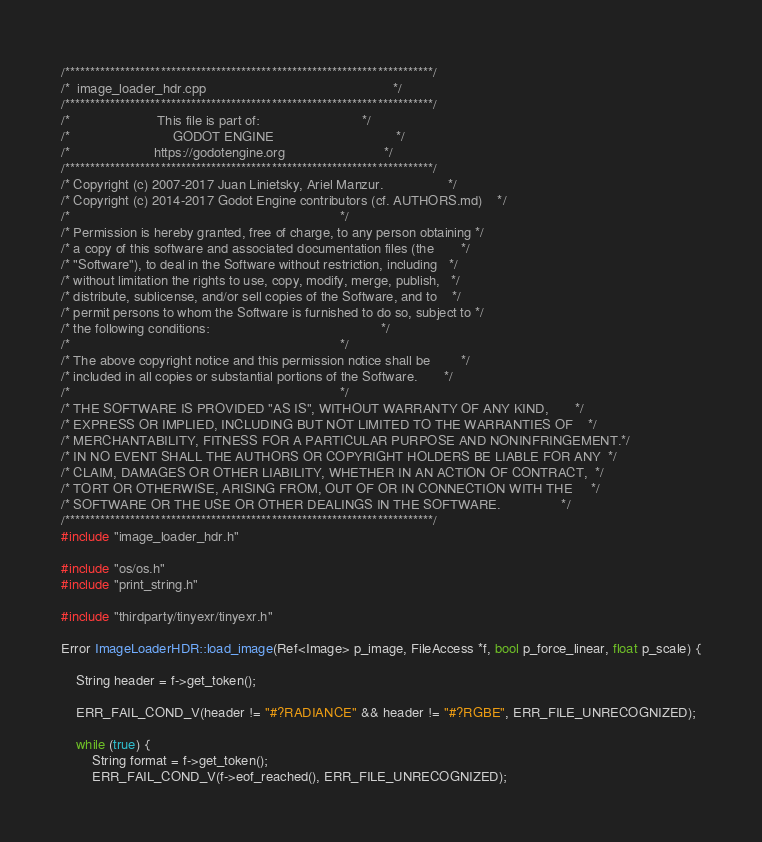<code> <loc_0><loc_0><loc_500><loc_500><_C++_>/*************************************************************************/
/*  image_loader_hdr.cpp                                                 */
/*************************************************************************/
/*                       This file is part of:                           */
/*                           GODOT ENGINE                                */
/*                      https://godotengine.org                          */
/*************************************************************************/
/* Copyright (c) 2007-2017 Juan Linietsky, Ariel Manzur.                 */
/* Copyright (c) 2014-2017 Godot Engine contributors (cf. AUTHORS.md)    */
/*                                                                       */
/* Permission is hereby granted, free of charge, to any person obtaining */
/* a copy of this software and associated documentation files (the       */
/* "Software"), to deal in the Software without restriction, including   */
/* without limitation the rights to use, copy, modify, merge, publish,   */
/* distribute, sublicense, and/or sell copies of the Software, and to    */
/* permit persons to whom the Software is furnished to do so, subject to */
/* the following conditions:                                             */
/*                                                                       */
/* The above copyright notice and this permission notice shall be        */
/* included in all copies or substantial portions of the Software.       */
/*                                                                       */
/* THE SOFTWARE IS PROVIDED "AS IS", WITHOUT WARRANTY OF ANY KIND,       */
/* EXPRESS OR IMPLIED, INCLUDING BUT NOT LIMITED TO THE WARRANTIES OF    */
/* MERCHANTABILITY, FITNESS FOR A PARTICULAR PURPOSE AND NONINFRINGEMENT.*/
/* IN NO EVENT SHALL THE AUTHORS OR COPYRIGHT HOLDERS BE LIABLE FOR ANY  */
/* CLAIM, DAMAGES OR OTHER LIABILITY, WHETHER IN AN ACTION OF CONTRACT,  */
/* TORT OR OTHERWISE, ARISING FROM, OUT OF OR IN CONNECTION WITH THE     */
/* SOFTWARE OR THE USE OR OTHER DEALINGS IN THE SOFTWARE.                */
/*************************************************************************/
#include "image_loader_hdr.h"

#include "os/os.h"
#include "print_string.h"

#include "thirdparty/tinyexr/tinyexr.h"

Error ImageLoaderHDR::load_image(Ref<Image> p_image, FileAccess *f, bool p_force_linear, float p_scale) {

	String header = f->get_token();

	ERR_FAIL_COND_V(header != "#?RADIANCE" && header != "#?RGBE", ERR_FILE_UNRECOGNIZED);

	while (true) {
		String format = f->get_token();
		ERR_FAIL_COND_V(f->eof_reached(), ERR_FILE_UNRECOGNIZED);</code> 